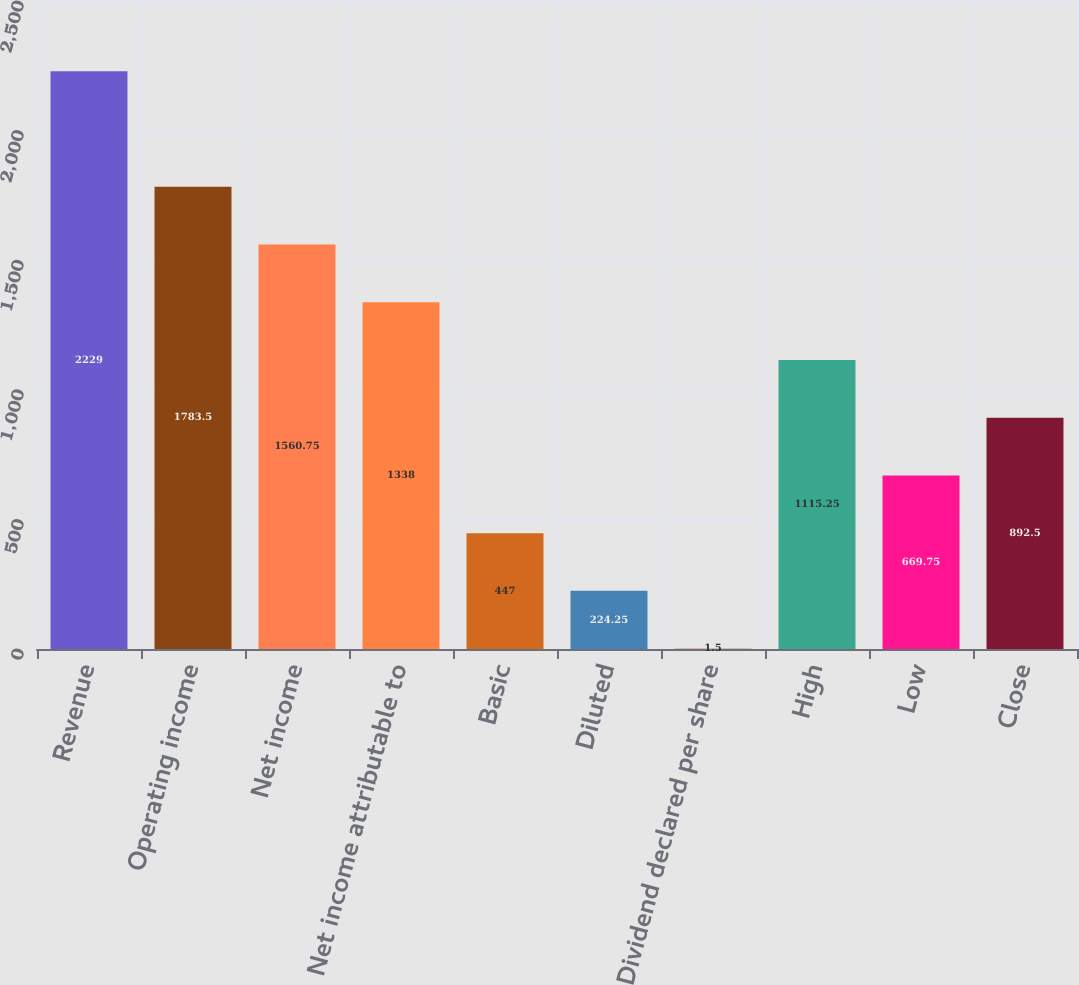Convert chart. <chart><loc_0><loc_0><loc_500><loc_500><bar_chart><fcel>Revenue<fcel>Operating income<fcel>Net income<fcel>Net income attributable to<fcel>Basic<fcel>Diluted<fcel>Dividend declared per share<fcel>High<fcel>Low<fcel>Close<nl><fcel>2229<fcel>1783.5<fcel>1560.75<fcel>1338<fcel>447<fcel>224.25<fcel>1.5<fcel>1115.25<fcel>669.75<fcel>892.5<nl></chart> 